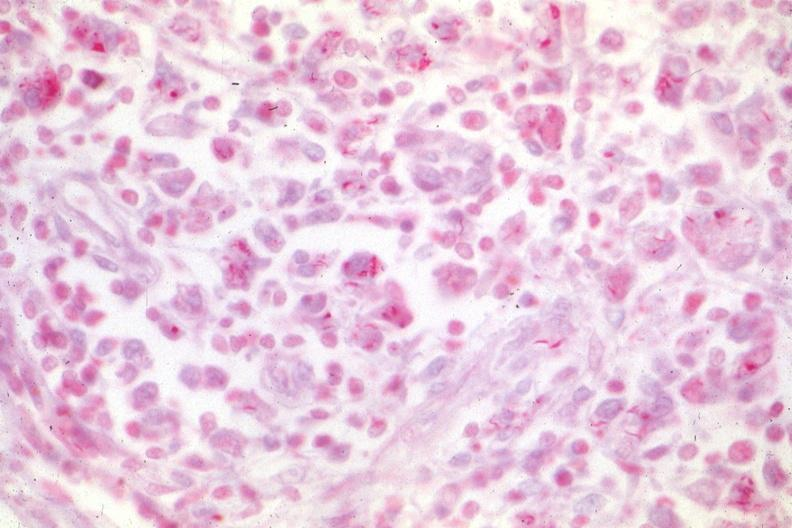how does this image show typical case of hemophilia?
Answer the question using a single word or phrase. With aids 